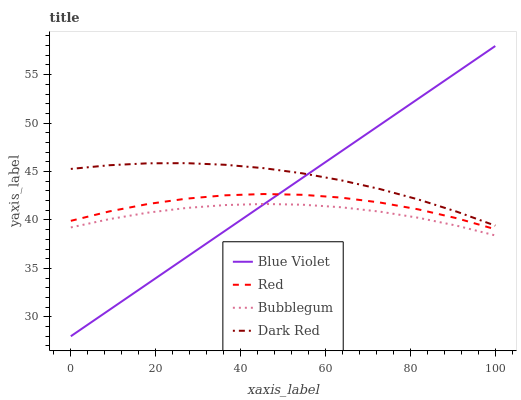Does Bubblegum have the minimum area under the curve?
Answer yes or no. Yes. Does Dark Red have the maximum area under the curve?
Answer yes or no. Yes. Does Red have the minimum area under the curve?
Answer yes or no. No. Does Red have the maximum area under the curve?
Answer yes or no. No. Is Blue Violet the smoothest?
Answer yes or no. Yes. Is Red the roughest?
Answer yes or no. Yes. Is Bubblegum the smoothest?
Answer yes or no. No. Is Bubblegum the roughest?
Answer yes or no. No. Does Blue Violet have the lowest value?
Answer yes or no. Yes. Does Bubblegum have the lowest value?
Answer yes or no. No. Does Blue Violet have the highest value?
Answer yes or no. Yes. Does Red have the highest value?
Answer yes or no. No. Is Bubblegum less than Dark Red?
Answer yes or no. Yes. Is Dark Red greater than Bubblegum?
Answer yes or no. Yes. Does Bubblegum intersect Blue Violet?
Answer yes or no. Yes. Is Bubblegum less than Blue Violet?
Answer yes or no. No. Is Bubblegum greater than Blue Violet?
Answer yes or no. No. Does Bubblegum intersect Dark Red?
Answer yes or no. No. 